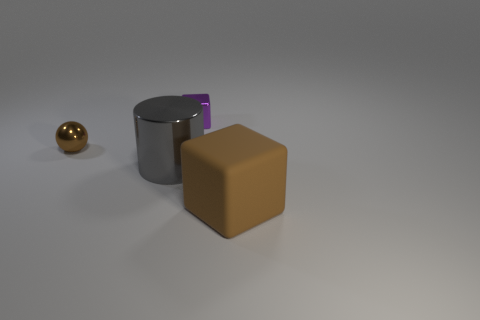Are there any other things that are made of the same material as the brown cube?
Keep it short and to the point. No. How many other things are there of the same material as the large brown thing?
Offer a very short reply. 0. Are there fewer small things than green metal spheres?
Offer a terse response. No. Is the material of the brown sphere the same as the cube in front of the tiny block?
Your answer should be very brief. No. The small metal object that is behind the brown metallic thing has what shape?
Your response must be concise. Cube. Is there any other thing that has the same color as the big block?
Offer a very short reply. Yes. Are there fewer large brown rubber things that are behind the big gray object than purple metallic cubes?
Provide a short and direct response. Yes. What number of gray metallic objects have the same size as the cylinder?
Your answer should be very brief. 0. There is another thing that is the same color as the large rubber object; what shape is it?
Keep it short and to the point. Sphere. What shape is the big thing that is to the left of the block that is on the left side of the brown object in front of the small brown ball?
Keep it short and to the point. Cylinder. 